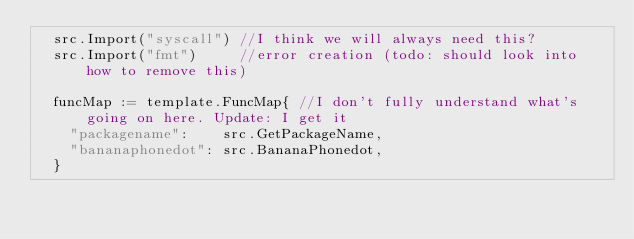Convert code to text. <code><loc_0><loc_0><loc_500><loc_500><_Go_>	src.Import("syscall") //I think we will always need this?
	src.Import("fmt")     //error creation (todo: should look into how to remove this)

	funcMap := template.FuncMap{ //I don't fully understand what's going on here. Update: I get it
		"packagename":    src.GetPackageName,
		"bananaphonedot": src.BananaPhonedot,
	}
</code> 